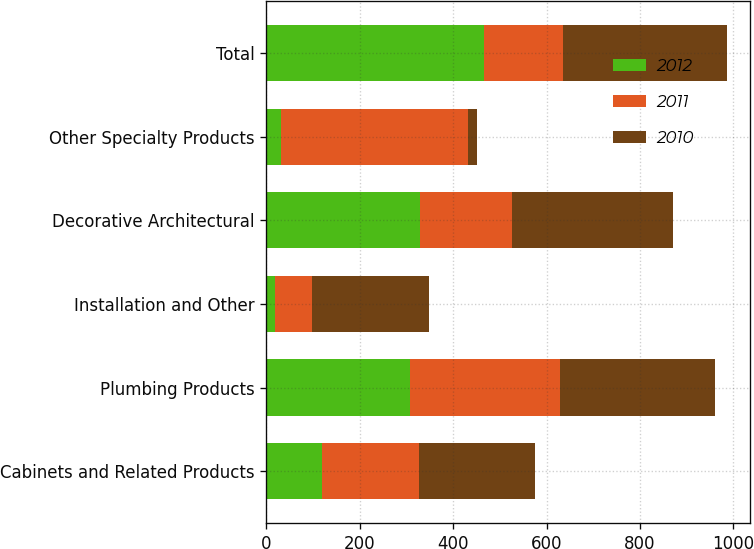<chart> <loc_0><loc_0><loc_500><loc_500><stacked_bar_chart><ecel><fcel>Cabinets and Related Products<fcel>Plumbing Products<fcel>Installation and Other<fcel>Decorative Architectural<fcel>Other Specialty Products<fcel>Total<nl><fcel>2012<fcel>120<fcel>307<fcel>19<fcel>329<fcel>31<fcel>466<nl><fcel>2011<fcel>206<fcel>322<fcel>79<fcel>196<fcel>401<fcel>168<nl><fcel>2010<fcel>250<fcel>331<fcel>250<fcel>345<fcel>19<fcel>353<nl></chart> 